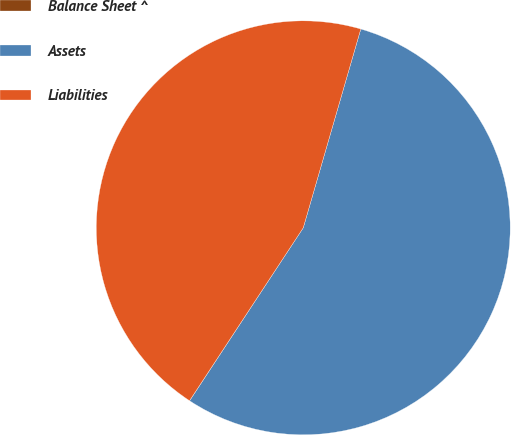<chart> <loc_0><loc_0><loc_500><loc_500><pie_chart><fcel>Balance Sheet ^<fcel>Assets<fcel>Liabilities<nl><fcel>0.01%<fcel>54.77%<fcel>45.23%<nl></chart> 